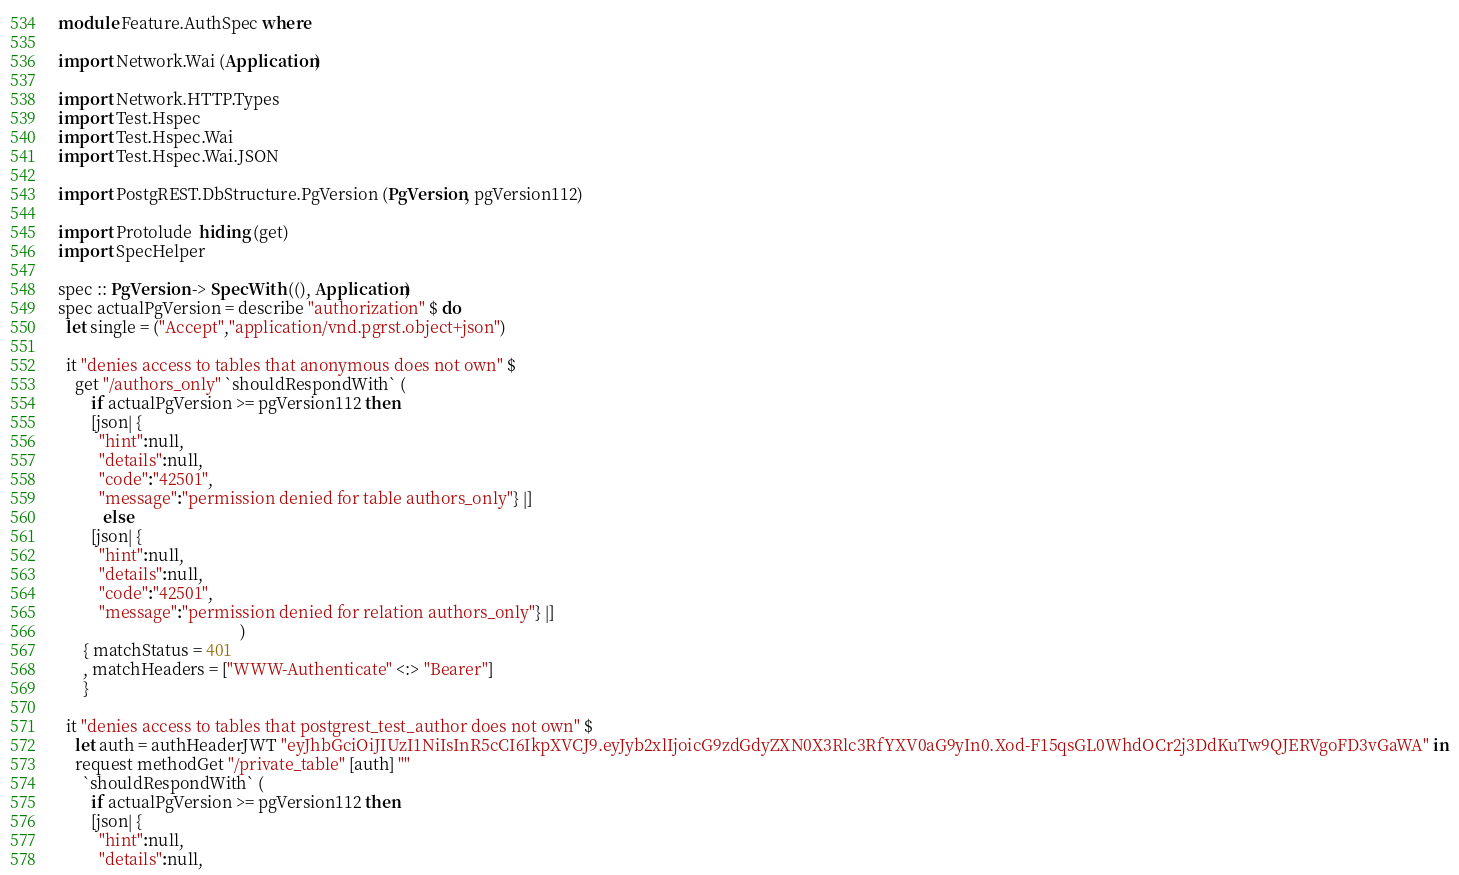<code> <loc_0><loc_0><loc_500><loc_500><_Haskell_>module Feature.AuthSpec where

import Network.Wai (Application)

import Network.HTTP.Types
import Test.Hspec
import Test.Hspec.Wai
import Test.Hspec.Wai.JSON

import PostgREST.DbStructure.PgVersion (PgVersion, pgVersion112)

import Protolude  hiding (get)
import SpecHelper

spec :: PgVersion -> SpecWith ((), Application)
spec actualPgVersion = describe "authorization" $ do
  let single = ("Accept","application/vnd.pgrst.object+json")

  it "denies access to tables that anonymous does not own" $
    get "/authors_only" `shouldRespondWith` (
        if actualPgVersion >= pgVersion112 then
        [json| {
          "hint":null,
          "details":null,
          "code":"42501",
          "message":"permission denied for table authors_only"} |]
           else
        [json| {
          "hint":null,
          "details":null,
          "code":"42501",
          "message":"permission denied for relation authors_only"} |]
                                            )
      { matchStatus = 401
      , matchHeaders = ["WWW-Authenticate" <:> "Bearer"]
      }

  it "denies access to tables that postgrest_test_author does not own" $
    let auth = authHeaderJWT "eyJhbGciOiJIUzI1NiIsInR5cCI6IkpXVCJ9.eyJyb2xlIjoicG9zdGdyZXN0X3Rlc3RfYXV0aG9yIn0.Xod-F15qsGL0WhdOCr2j3DdKuTw9QJERVgoFD3vGaWA" in
    request methodGet "/private_table" [auth] ""
      `shouldRespondWith` (
        if actualPgVersion >= pgVersion112 then
        [json| {
          "hint":null,
          "details":null,</code> 